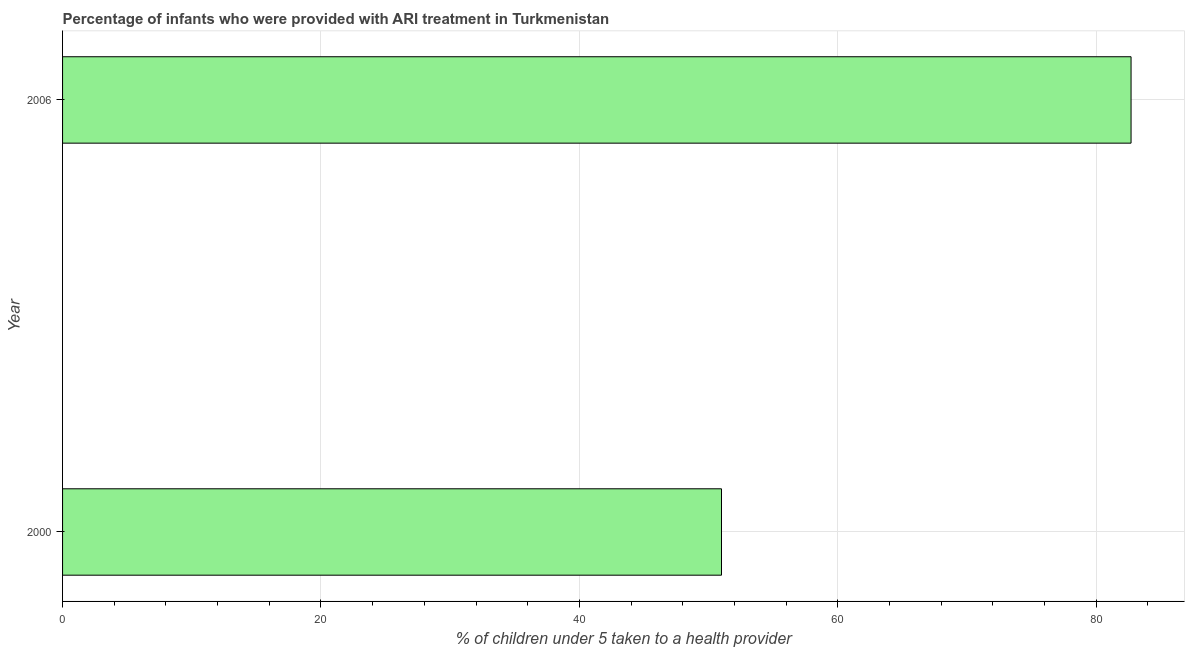Does the graph contain any zero values?
Provide a succinct answer. No. What is the title of the graph?
Offer a terse response. Percentage of infants who were provided with ARI treatment in Turkmenistan. What is the label or title of the X-axis?
Offer a terse response. % of children under 5 taken to a health provider. Across all years, what is the maximum percentage of children who were provided with ari treatment?
Your answer should be very brief. 82.7. In which year was the percentage of children who were provided with ari treatment maximum?
Your answer should be compact. 2006. What is the sum of the percentage of children who were provided with ari treatment?
Give a very brief answer. 133.7. What is the difference between the percentage of children who were provided with ari treatment in 2000 and 2006?
Your answer should be very brief. -31.7. What is the average percentage of children who were provided with ari treatment per year?
Offer a very short reply. 66.85. What is the median percentage of children who were provided with ari treatment?
Offer a terse response. 66.85. In how many years, is the percentage of children who were provided with ari treatment greater than 68 %?
Provide a short and direct response. 1. Do a majority of the years between 2000 and 2006 (inclusive) have percentage of children who were provided with ari treatment greater than 20 %?
Your answer should be compact. Yes. What is the ratio of the percentage of children who were provided with ari treatment in 2000 to that in 2006?
Give a very brief answer. 0.62. In how many years, is the percentage of children who were provided with ari treatment greater than the average percentage of children who were provided with ari treatment taken over all years?
Provide a succinct answer. 1. Are all the bars in the graph horizontal?
Offer a very short reply. Yes. What is the % of children under 5 taken to a health provider of 2006?
Your answer should be very brief. 82.7. What is the difference between the % of children under 5 taken to a health provider in 2000 and 2006?
Your response must be concise. -31.7. What is the ratio of the % of children under 5 taken to a health provider in 2000 to that in 2006?
Your response must be concise. 0.62. 